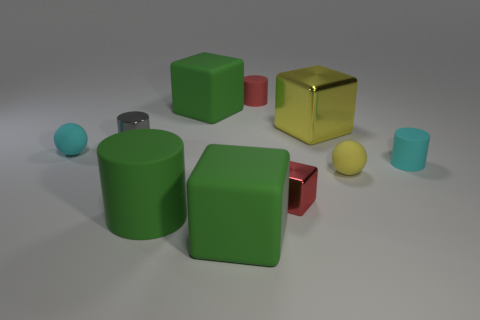Subtract 1 blocks. How many blocks are left? 3 Subtract all metal cylinders. How many cylinders are left? 3 Subtract all yellow cylinders. Subtract all yellow balls. How many cylinders are left? 4 Subtract all cylinders. How many objects are left? 6 Subtract 0 blue cylinders. How many objects are left? 10 Subtract all small green matte cylinders. Subtract all small red rubber cylinders. How many objects are left? 9 Add 5 red metal objects. How many red metal objects are left? 6 Add 8 small cyan matte cubes. How many small cyan matte cubes exist? 8 